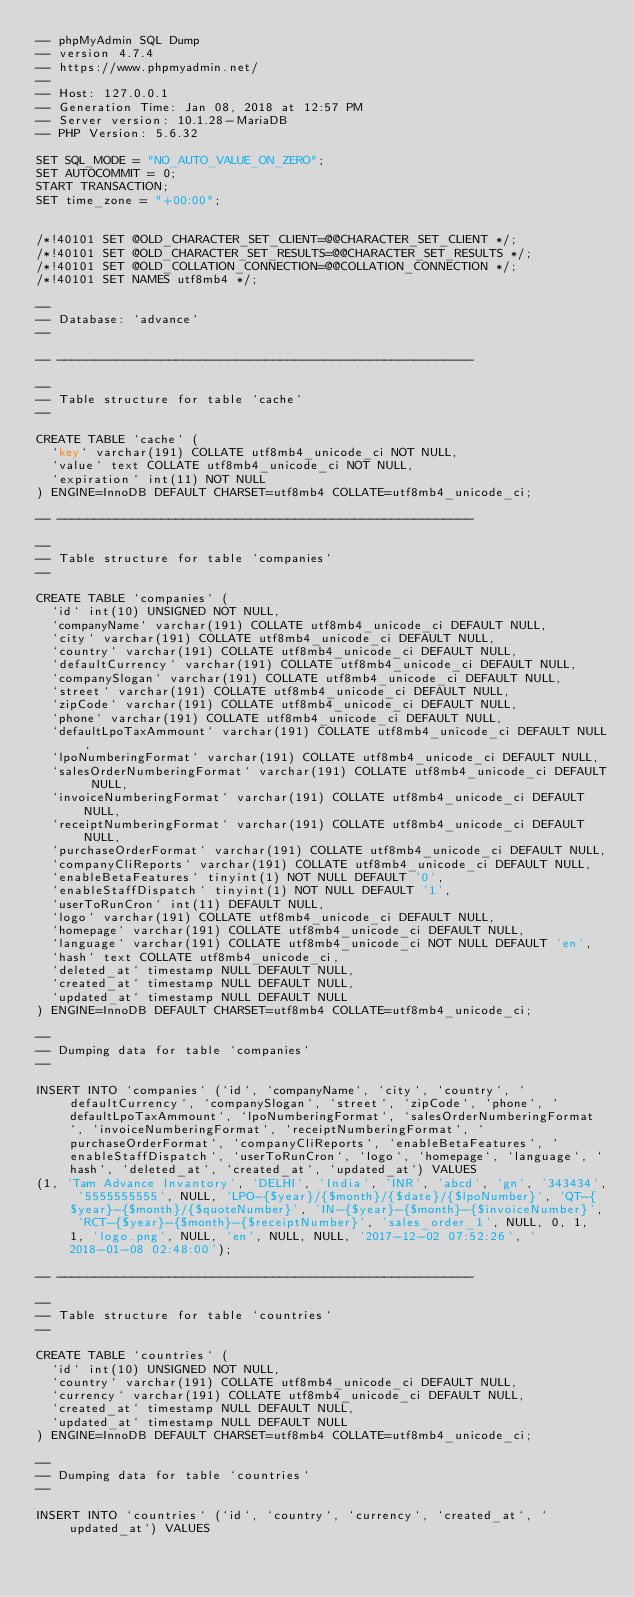<code> <loc_0><loc_0><loc_500><loc_500><_SQL_>-- phpMyAdmin SQL Dump
-- version 4.7.4
-- https://www.phpmyadmin.net/
--
-- Host: 127.0.0.1
-- Generation Time: Jan 08, 2018 at 12:57 PM
-- Server version: 10.1.28-MariaDB
-- PHP Version: 5.6.32

SET SQL_MODE = "NO_AUTO_VALUE_ON_ZERO";
SET AUTOCOMMIT = 0;
START TRANSACTION;
SET time_zone = "+00:00";


/*!40101 SET @OLD_CHARACTER_SET_CLIENT=@@CHARACTER_SET_CLIENT */;
/*!40101 SET @OLD_CHARACTER_SET_RESULTS=@@CHARACTER_SET_RESULTS */;
/*!40101 SET @OLD_COLLATION_CONNECTION=@@COLLATION_CONNECTION */;
/*!40101 SET NAMES utf8mb4 */;

--
-- Database: `advance`
--

-- --------------------------------------------------------

--
-- Table structure for table `cache`
--

CREATE TABLE `cache` (
  `key` varchar(191) COLLATE utf8mb4_unicode_ci NOT NULL,
  `value` text COLLATE utf8mb4_unicode_ci NOT NULL,
  `expiration` int(11) NOT NULL
) ENGINE=InnoDB DEFAULT CHARSET=utf8mb4 COLLATE=utf8mb4_unicode_ci;

-- --------------------------------------------------------

--
-- Table structure for table `companies`
--

CREATE TABLE `companies` (
  `id` int(10) UNSIGNED NOT NULL,
  `companyName` varchar(191) COLLATE utf8mb4_unicode_ci DEFAULT NULL,
  `city` varchar(191) COLLATE utf8mb4_unicode_ci DEFAULT NULL,
  `country` varchar(191) COLLATE utf8mb4_unicode_ci DEFAULT NULL,
  `defaultCurrency` varchar(191) COLLATE utf8mb4_unicode_ci DEFAULT NULL,
  `companySlogan` varchar(191) COLLATE utf8mb4_unicode_ci DEFAULT NULL,
  `street` varchar(191) COLLATE utf8mb4_unicode_ci DEFAULT NULL,
  `zipCode` varchar(191) COLLATE utf8mb4_unicode_ci DEFAULT NULL,
  `phone` varchar(191) COLLATE utf8mb4_unicode_ci DEFAULT NULL,
  `defaultLpoTaxAmmount` varchar(191) COLLATE utf8mb4_unicode_ci DEFAULT NULL,
  `lpoNumberingFormat` varchar(191) COLLATE utf8mb4_unicode_ci DEFAULT NULL,
  `salesOrderNumberingFormat` varchar(191) COLLATE utf8mb4_unicode_ci DEFAULT NULL,
  `invoiceNumberingFormat` varchar(191) COLLATE utf8mb4_unicode_ci DEFAULT NULL,
  `receiptNumberingFormat` varchar(191) COLLATE utf8mb4_unicode_ci DEFAULT NULL,
  `purchaseOrderFormat` varchar(191) COLLATE utf8mb4_unicode_ci DEFAULT NULL,
  `companyCliReports` varchar(191) COLLATE utf8mb4_unicode_ci DEFAULT NULL,
  `enableBetaFeatures` tinyint(1) NOT NULL DEFAULT '0',
  `enableStaffDispatch` tinyint(1) NOT NULL DEFAULT '1',
  `userToRunCron` int(11) DEFAULT NULL,
  `logo` varchar(191) COLLATE utf8mb4_unicode_ci DEFAULT NULL,
  `homepage` varchar(191) COLLATE utf8mb4_unicode_ci DEFAULT NULL,
  `language` varchar(191) COLLATE utf8mb4_unicode_ci NOT NULL DEFAULT 'en',
  `hash` text COLLATE utf8mb4_unicode_ci,
  `deleted_at` timestamp NULL DEFAULT NULL,
  `created_at` timestamp NULL DEFAULT NULL,
  `updated_at` timestamp NULL DEFAULT NULL
) ENGINE=InnoDB DEFAULT CHARSET=utf8mb4 COLLATE=utf8mb4_unicode_ci;

--
-- Dumping data for table `companies`
--

INSERT INTO `companies` (`id`, `companyName`, `city`, `country`, `defaultCurrency`, `companySlogan`, `street`, `zipCode`, `phone`, `defaultLpoTaxAmmount`, `lpoNumberingFormat`, `salesOrderNumberingFormat`, `invoiceNumberingFormat`, `receiptNumberingFormat`, `purchaseOrderFormat`, `companyCliReports`, `enableBetaFeatures`, `enableStaffDispatch`, `userToRunCron`, `logo`, `homepage`, `language`, `hash`, `deleted_at`, `created_at`, `updated_at`) VALUES
(1, 'Tam Advance Invantory', 'DELHI', 'India', 'INR', 'abcd', 'gn', '343434', '5555555555', NULL, 'LPO-{$year}/{$month}/{$date}/{$lpoNumber}', 'QT-{$year}-{$month}/{$quoteNumber}', 'IN-{$year}-{$month}-{$invoiceNumber}', 'RCT-{$year}-{$month}-{$receiptNumber}', 'sales_order_1', NULL, 0, 1, 1, 'logo.png', NULL, 'en', NULL, NULL, '2017-12-02 07:52:26', '2018-01-08 02:48:00');

-- --------------------------------------------------------

--
-- Table structure for table `countries`
--

CREATE TABLE `countries` (
  `id` int(10) UNSIGNED NOT NULL,
  `country` varchar(191) COLLATE utf8mb4_unicode_ci DEFAULT NULL,
  `currency` varchar(191) COLLATE utf8mb4_unicode_ci DEFAULT NULL,
  `created_at` timestamp NULL DEFAULT NULL,
  `updated_at` timestamp NULL DEFAULT NULL
) ENGINE=InnoDB DEFAULT CHARSET=utf8mb4 COLLATE=utf8mb4_unicode_ci;

--
-- Dumping data for table `countries`
--

INSERT INTO `countries` (`id`, `country`, `currency`, `created_at`, `updated_at`) VALUES</code> 